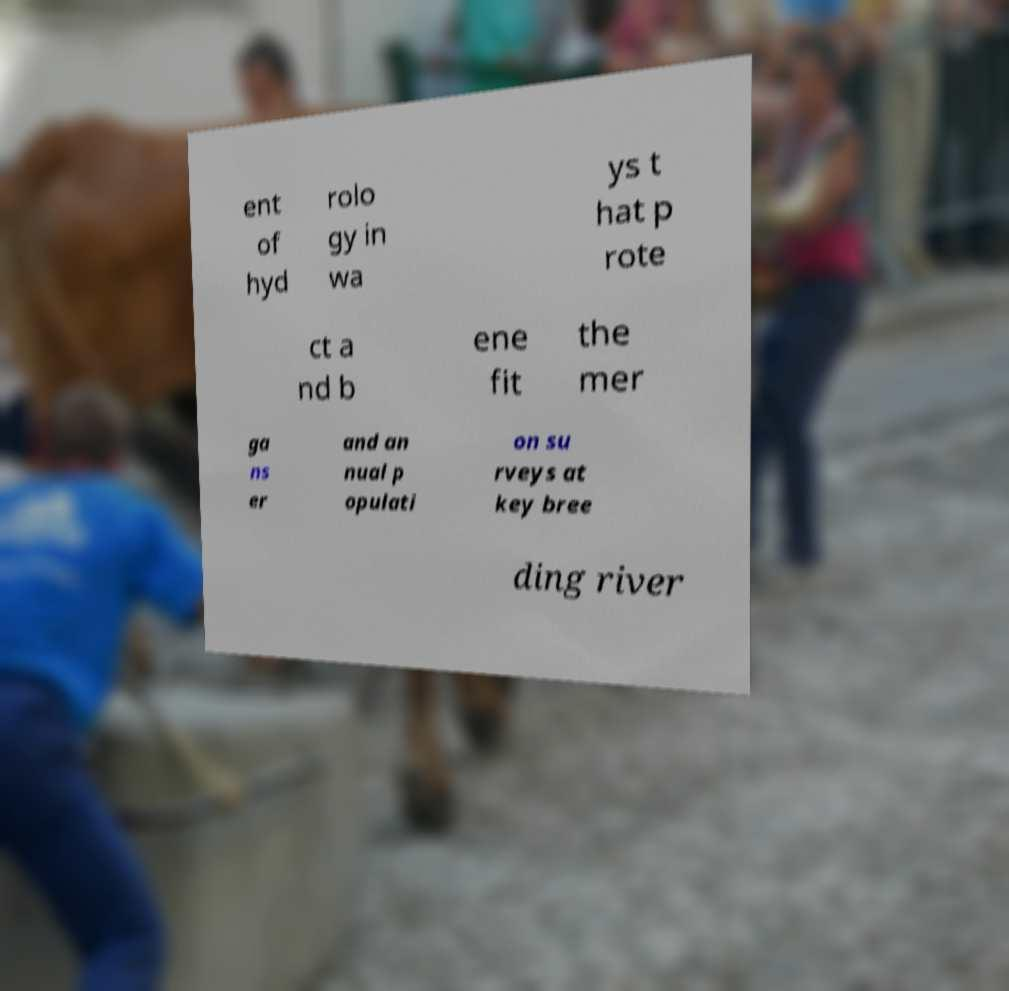Could you assist in decoding the text presented in this image and type it out clearly? ent of hyd rolo gy in wa ys t hat p rote ct a nd b ene fit the mer ga ns er and an nual p opulati on su rveys at key bree ding river 